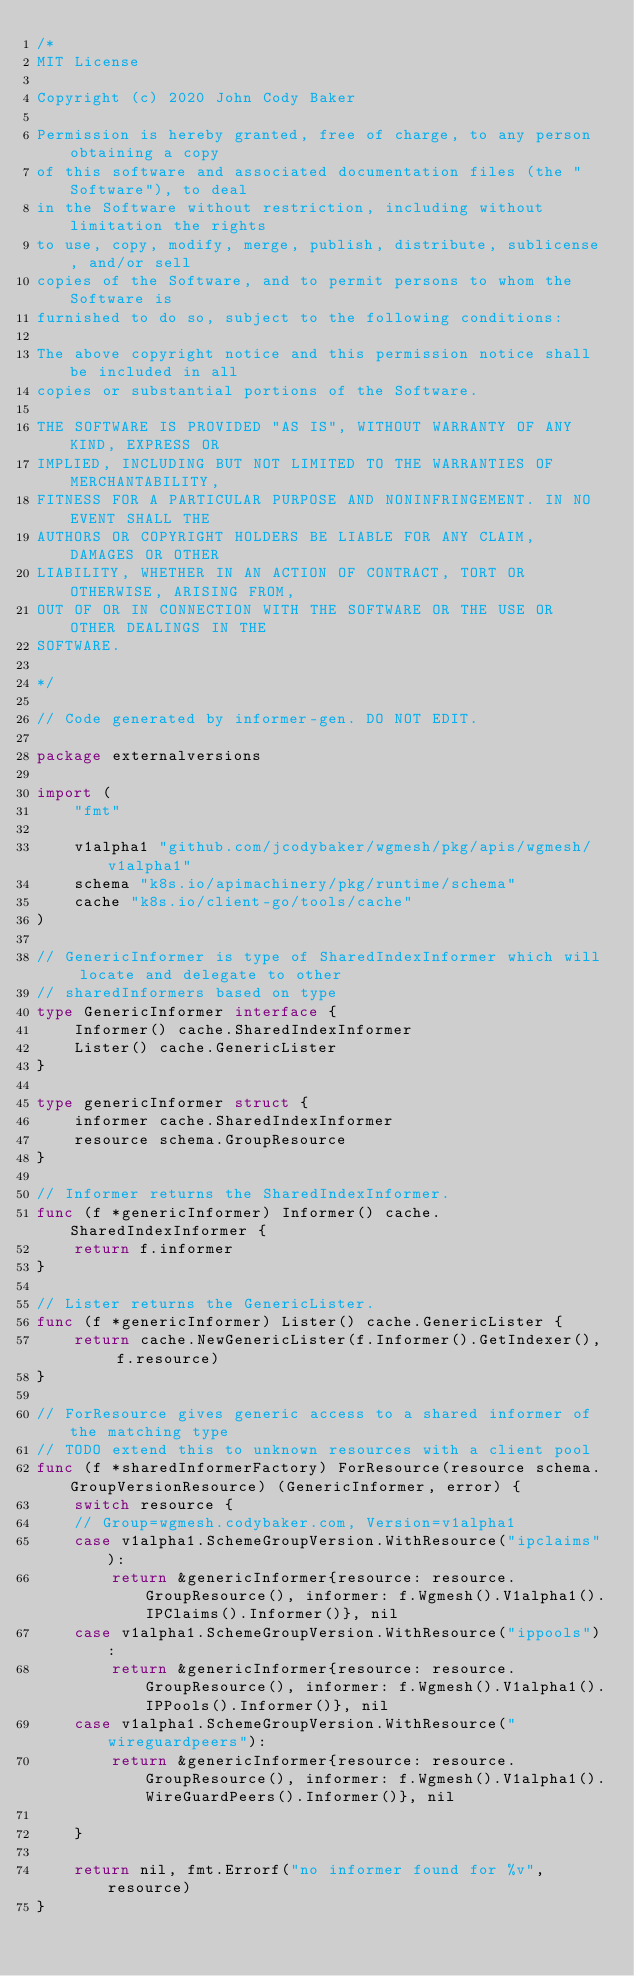Convert code to text. <code><loc_0><loc_0><loc_500><loc_500><_Go_>/*
MIT License

Copyright (c) 2020 John Cody Baker

Permission is hereby granted, free of charge, to any person obtaining a copy
of this software and associated documentation files (the "Software"), to deal
in the Software without restriction, including without limitation the rights
to use, copy, modify, merge, publish, distribute, sublicense, and/or sell
copies of the Software, and to permit persons to whom the Software is
furnished to do so, subject to the following conditions:

The above copyright notice and this permission notice shall be included in all
copies or substantial portions of the Software.

THE SOFTWARE IS PROVIDED "AS IS", WITHOUT WARRANTY OF ANY KIND, EXPRESS OR
IMPLIED, INCLUDING BUT NOT LIMITED TO THE WARRANTIES OF MERCHANTABILITY,
FITNESS FOR A PARTICULAR PURPOSE AND NONINFRINGEMENT. IN NO EVENT SHALL THE
AUTHORS OR COPYRIGHT HOLDERS BE LIABLE FOR ANY CLAIM, DAMAGES OR OTHER
LIABILITY, WHETHER IN AN ACTION OF CONTRACT, TORT OR OTHERWISE, ARISING FROM,
OUT OF OR IN CONNECTION WITH THE SOFTWARE OR THE USE OR OTHER DEALINGS IN THE
SOFTWARE.

*/

// Code generated by informer-gen. DO NOT EDIT.

package externalversions

import (
	"fmt"

	v1alpha1 "github.com/jcodybaker/wgmesh/pkg/apis/wgmesh/v1alpha1"
	schema "k8s.io/apimachinery/pkg/runtime/schema"
	cache "k8s.io/client-go/tools/cache"
)

// GenericInformer is type of SharedIndexInformer which will locate and delegate to other
// sharedInformers based on type
type GenericInformer interface {
	Informer() cache.SharedIndexInformer
	Lister() cache.GenericLister
}

type genericInformer struct {
	informer cache.SharedIndexInformer
	resource schema.GroupResource
}

// Informer returns the SharedIndexInformer.
func (f *genericInformer) Informer() cache.SharedIndexInformer {
	return f.informer
}

// Lister returns the GenericLister.
func (f *genericInformer) Lister() cache.GenericLister {
	return cache.NewGenericLister(f.Informer().GetIndexer(), f.resource)
}

// ForResource gives generic access to a shared informer of the matching type
// TODO extend this to unknown resources with a client pool
func (f *sharedInformerFactory) ForResource(resource schema.GroupVersionResource) (GenericInformer, error) {
	switch resource {
	// Group=wgmesh.codybaker.com, Version=v1alpha1
	case v1alpha1.SchemeGroupVersion.WithResource("ipclaims"):
		return &genericInformer{resource: resource.GroupResource(), informer: f.Wgmesh().V1alpha1().IPClaims().Informer()}, nil
	case v1alpha1.SchemeGroupVersion.WithResource("ippools"):
		return &genericInformer{resource: resource.GroupResource(), informer: f.Wgmesh().V1alpha1().IPPools().Informer()}, nil
	case v1alpha1.SchemeGroupVersion.WithResource("wireguardpeers"):
		return &genericInformer{resource: resource.GroupResource(), informer: f.Wgmesh().V1alpha1().WireGuardPeers().Informer()}, nil

	}

	return nil, fmt.Errorf("no informer found for %v", resource)
}
</code> 